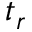Convert formula to latex. <formula><loc_0><loc_0><loc_500><loc_500>t _ { r }</formula> 